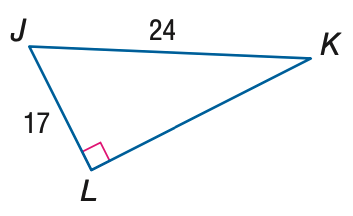Answer the mathemtical geometry problem and directly provide the correct option letter.
Question: Use a calculator to find the measure of \angle J to the nearest degree.
Choices: A: 35 B: 45 C: 55 D: 65 B 